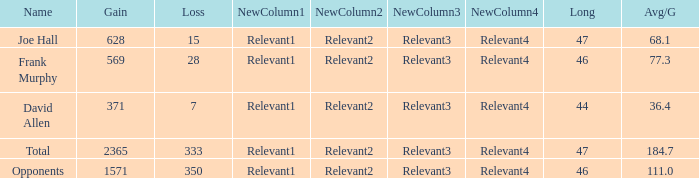How much Loss has a Gain smaller than 1571, and a Long smaller than 47, and an Avg/G of 36.4? 1.0. 